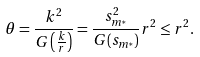<formula> <loc_0><loc_0><loc_500><loc_500>\theta = \frac { k ^ { 2 } } { G \left ( \frac { k } { r } \right ) } = \frac { s _ { m ^ { * } } ^ { 2 } } { G ( s _ { m ^ { * } } ) } r ^ { 2 } \leq r ^ { 2 } .</formula> 